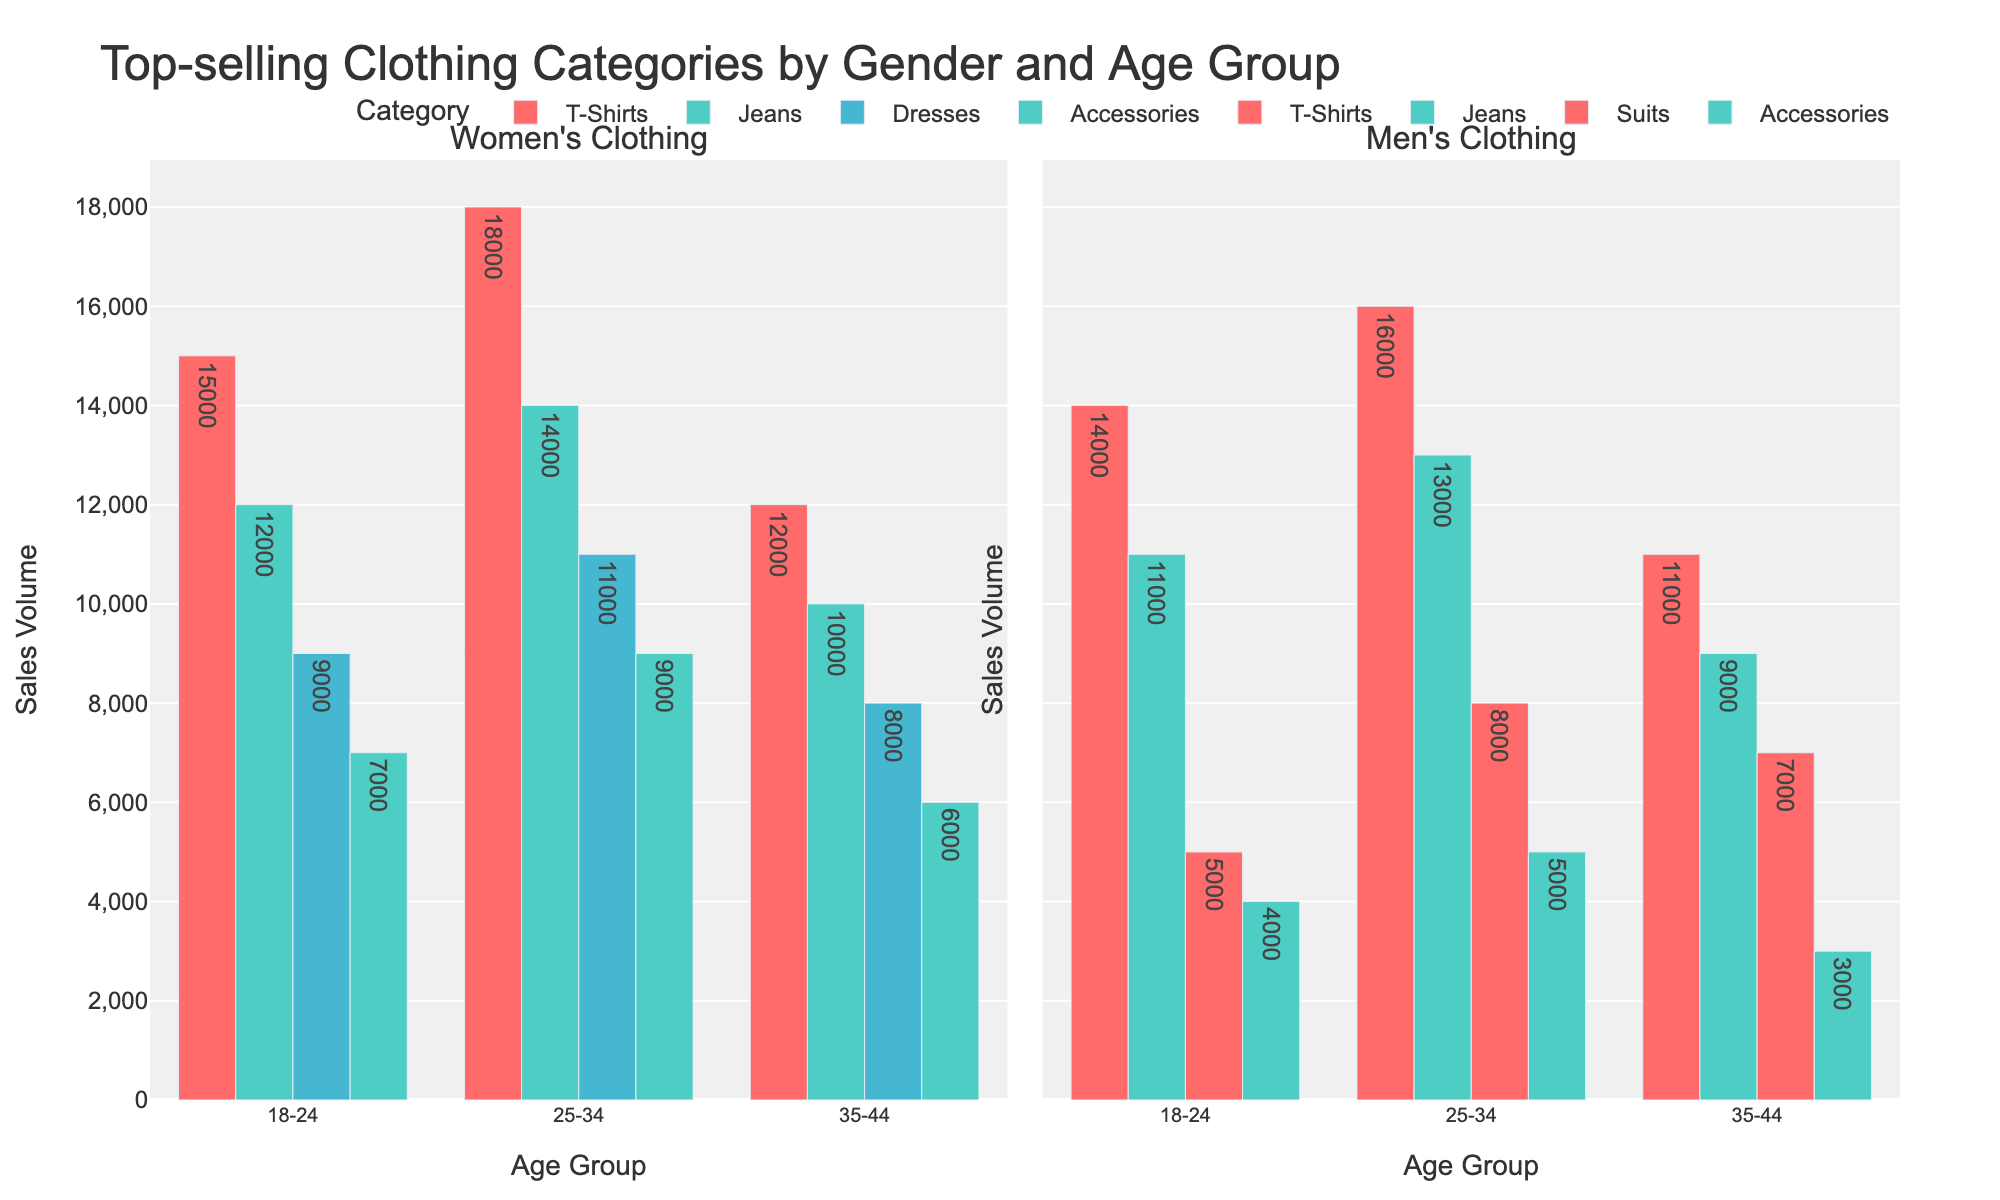Which age group of men bought the most T-Shirts? The bar chart for men's clothing categories shows that the 25-34 age group has the highest sales volume for T-Shirts.
Answer: 25-34 How do sales volumes for women's dresses compare between the 18-24 and 25-34 age groups? On the women's side, the bar for dresses shows a higher volume for the 25-34 age group compared to the 18-24 age group. The exact volumes are 11,000 and 9,000 respectively.
Answer: The 25-34 age group has higher sales What's the total sales volume of accessories for men across all age groups? The sales volumes for men's accessories in each age group are 4,000 (18-24), 5,000 (25-34), and 3,000 (35-44). Summing these, we get 4,000 + 5,000 + 3,000 = 12,000.
Answer: 12,000 Which category has the highest total sales volume for women aged 25-34? In the women's 25-34 age group, the sales volumes are T-Shirts (18,000), Jeans (14,000), Dresses (11,000), and Accessories (9,000). T-Shirts have the highest sales volume.
Answer: T-Shirts Compare the sales volumes of men's suits for the 18-24 and 35-44 age groups. For men's suits, the sales volumes are 5,000 in the 18-24 age group and 7,000 in the 35-44 age group.
Answer: The 35-44 age group has higher sales What is the difference in sales volume between women's and men's jeans in the 18-24 age group? Women's jeans in the 18-24 age group have a sales volume of 12,000, and men's have 11,000. The difference is 12,000 - 11,000 = 1,000.
Answer: 1,000 How do the sales volumes of T-Shirts and jeans for men aged 25-34 compare? For men aged 25-34, the sales volumes are T-Shirts (16,000) and Jeans (13,000).
Answer: T-Shirts have higher sales Which category has the lowest sales volume for women aged 35-44? For women aged 35-44, the sales volumes are T-Shirts (12,000), Jeans (10,000), Dresses (8,000), and Accessories (6,000). Accessories have the lowest sales volume.
Answer: Accessories Across all age groups, do men's or women's accessories have higher total sales volume? Summing the sales for all age groups, women's accessories are 7,000 (18-24) + 9,000 (25-34) + 6,000 (35-44) = 22,000. Men's accessories are 4,000 (18-24) + 5,000 (25-34) + 3,000 (35-44) = 12,000. Women's accessories have higher sales volume.
Answer: Women's How does the sales volume for men's suits in the 25-34 age group compare to women's dresses in the same age group? Men's suits in the 25-34 age group have a sales volume of 8,000, whereas women's dresses have a sales volume of 11,000.
Answer: Women's dresses have higher sales 